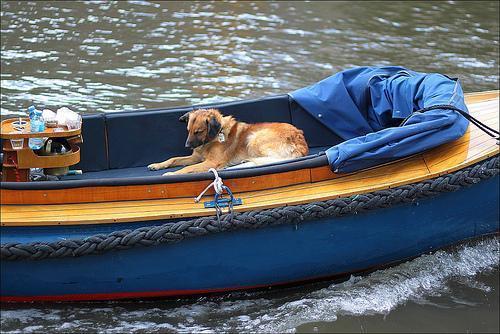How many dogs are in the image?
Give a very brief answer. 1. 